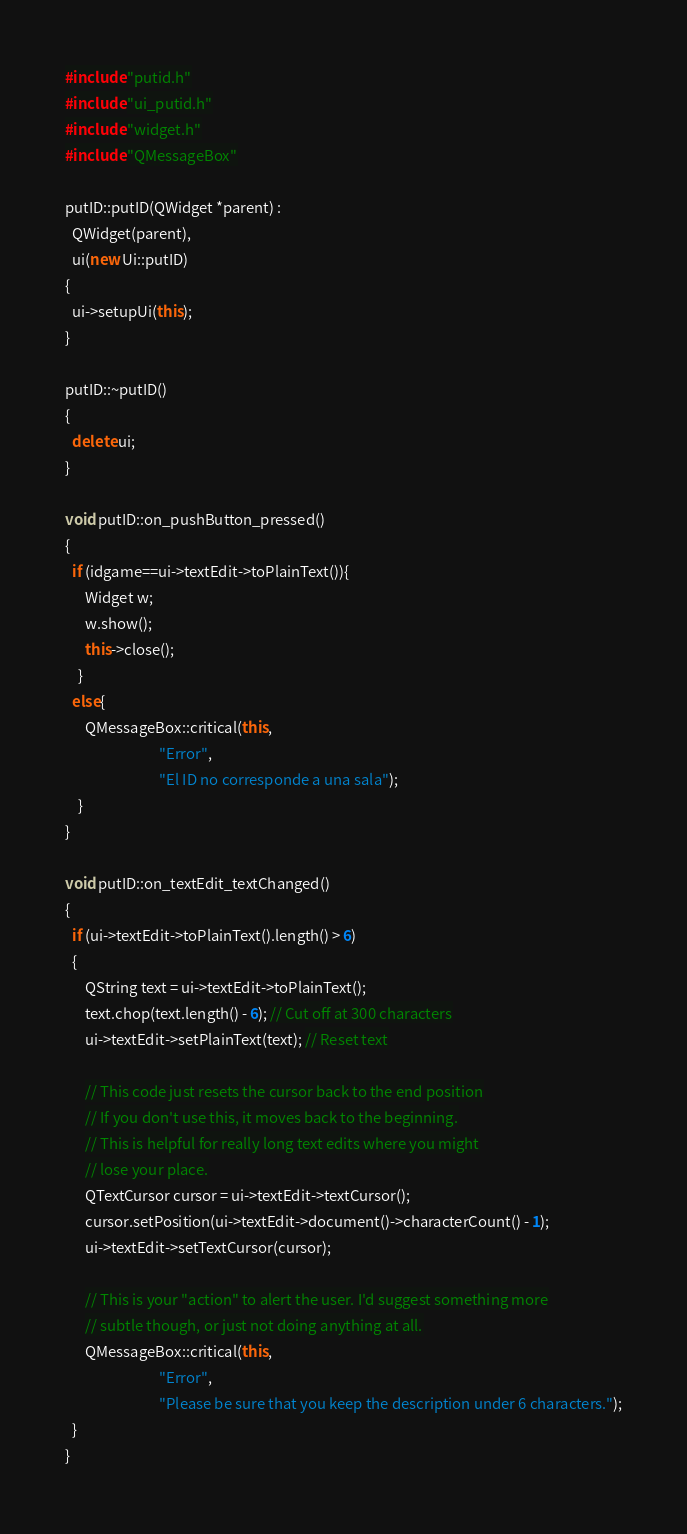<code> <loc_0><loc_0><loc_500><loc_500><_C++_>#include "putid.h"
#include "ui_putid.h"
#include "widget.h"
#include "QMessageBox"

putID::putID(QWidget *parent) :
  QWidget(parent),
  ui(new Ui::putID)
{
  ui->setupUi(this);
}

putID::~putID()
{
  delete ui;
}

void putID::on_pushButton_pressed()
{
  if (idgame==ui->textEdit->toPlainText()){
      Widget w;
      w.show();
      this->close();
    }
  else{
      QMessageBox::critical(this,
                            "Error",
                            "El ID no corresponde a una sala");
    }
}

void putID::on_textEdit_textChanged()
{
  if (ui->textEdit->toPlainText().length() > 6)
  {
      QString text = ui->textEdit->toPlainText();
      text.chop(text.length() - 6); // Cut off at 300 characters
      ui->textEdit->setPlainText(text); // Reset text

      // This code just resets the cursor back to the end position
      // If you don't use this, it moves back to the beginning.
      // This is helpful for really long text edits where you might
      // lose your place.
      QTextCursor cursor = ui->textEdit->textCursor();
      cursor.setPosition(ui->textEdit->document()->characterCount() - 1);
      ui->textEdit->setTextCursor(cursor);

      // This is your "action" to alert the user. I'd suggest something more
      // subtle though, or just not doing anything at all.
      QMessageBox::critical(this,
                            "Error",
                            "Please be sure that you keep the description under 6 characters.");
  }
}
</code> 